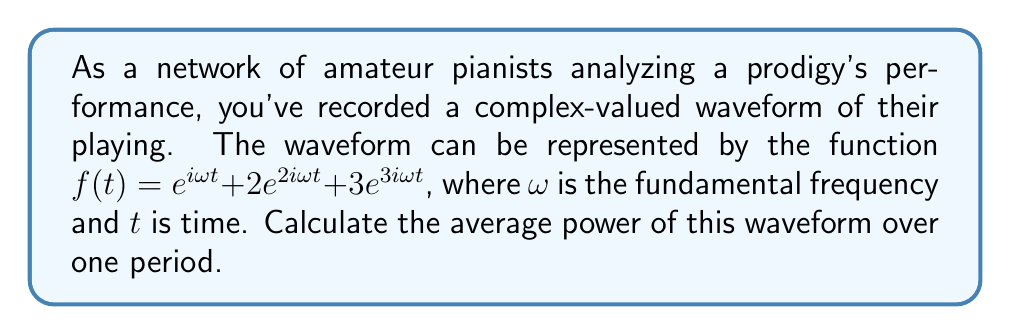Could you help me with this problem? To analyze the harmonic properties of this complex-valued musical waveform, we need to calculate its average power. Let's approach this step-by-step:

1) The average power of a complex-valued waveform over one period $T$ is given by:

   $$P_{avg} = \frac{1}{T} \int_0^T |f(t)|^2 dt$$

2) In our case, $f(t) = e^{i\omega t} + 2e^{2i\omega t} + 3e^{3i\omega t}$

3) We need to calculate $|f(t)|^2$:
   
   $$|f(t)|^2 = f(t) \cdot \overline{f(t)}$$
   
   where $\overline{f(t)}$ is the complex conjugate of $f(t)$

4) $\overline{f(t)} = e^{-i\omega t} + 2e^{-2i\omega t} + 3e^{-3i\omega t}$

5) Multiplying $f(t)$ and $\overline{f(t)}$:

   $$|f(t)|^2 = (e^{i\omega t} + 2e^{2i\omega t} + 3e^{3i\omega t})(e^{-i\omega t} + 2e^{-2i\omega t} + 3e^{-3i\omega t})$$

6) Expanding this:

   $$|f(t)|^2 = 1 + 4 + 9 + 2\cos(\omega t) + 4\cos(2\omega t) + 6\cos(3\omega t) + 6\cos(\omega t) + 6\cos(2\omega t) + 6\cos(\omega t)$$

7) Simplifying:

   $$|f(t)|^2 = 14 + 14\cos(\omega t) + 10\cos(2\omega t) + 6\cos(3\omega t)$$

8) Now, we need to integrate this over one period. The period $T = \frac{2\pi}{\omega}$

   $$P_{avg} = \frac{1}{T} \int_0^T (14 + 14\cos(\omega t) + 10\cos(2\omega t) + 6\cos(3\omega t)) dt$$

9) The integral of cosine over its period is zero, so all cosine terms will vanish:

   $$P_{avg} = \frac{1}{T} \int_0^T 14 dt = 14$$

Therefore, the average power of the waveform is 14.
Answer: The average power of the waveform is 14. 